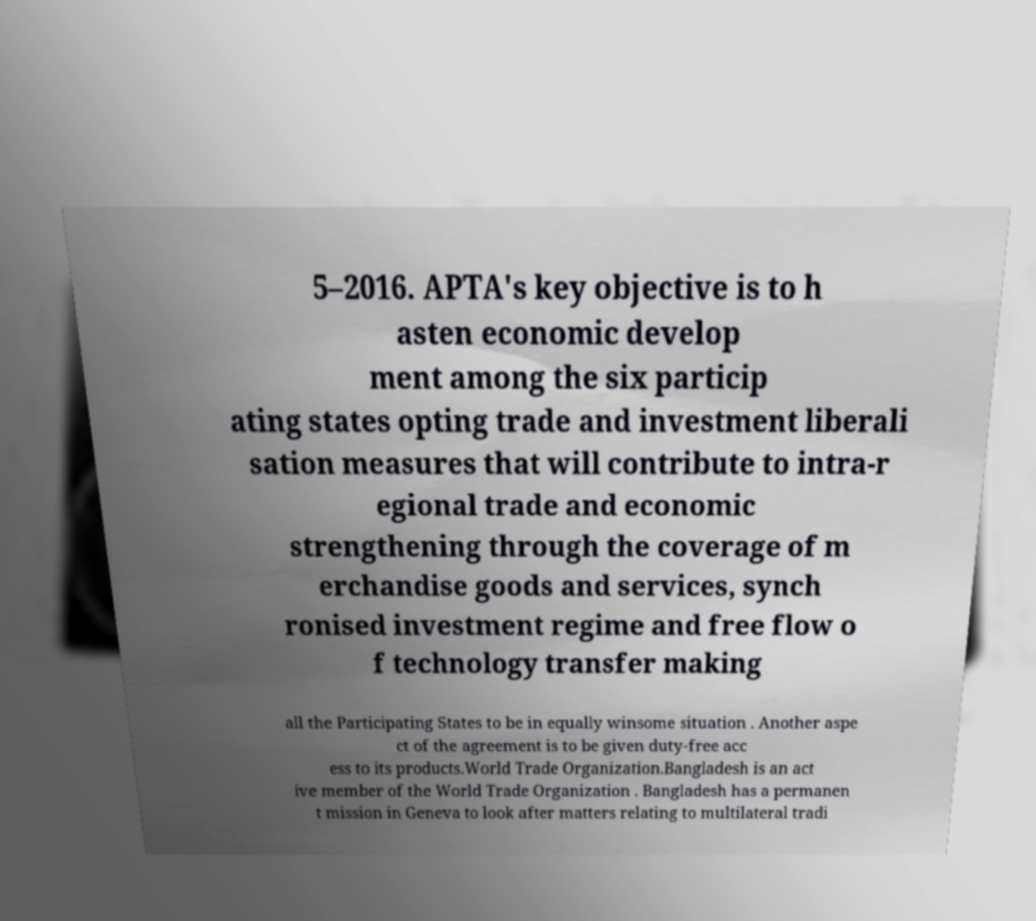Can you accurately transcribe the text from the provided image for me? 5–2016. APTA's key objective is to h asten economic develop ment among the six particip ating states opting trade and investment liberali sation measures that will contribute to intra-r egional trade and economic strengthening through the coverage of m erchandise goods and services, synch ronised investment regime and free flow o f technology transfer making all the Participating States to be in equally winsome situation . Another aspe ct of the agreement is to be given duty-free acc ess to its products.World Trade Organization.Bangladesh is an act ive member of the World Trade Organization . Bangladesh has a permanen t mission in Geneva to look after matters relating to multilateral tradi 